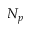Convert formula to latex. <formula><loc_0><loc_0><loc_500><loc_500>N _ { p }</formula> 